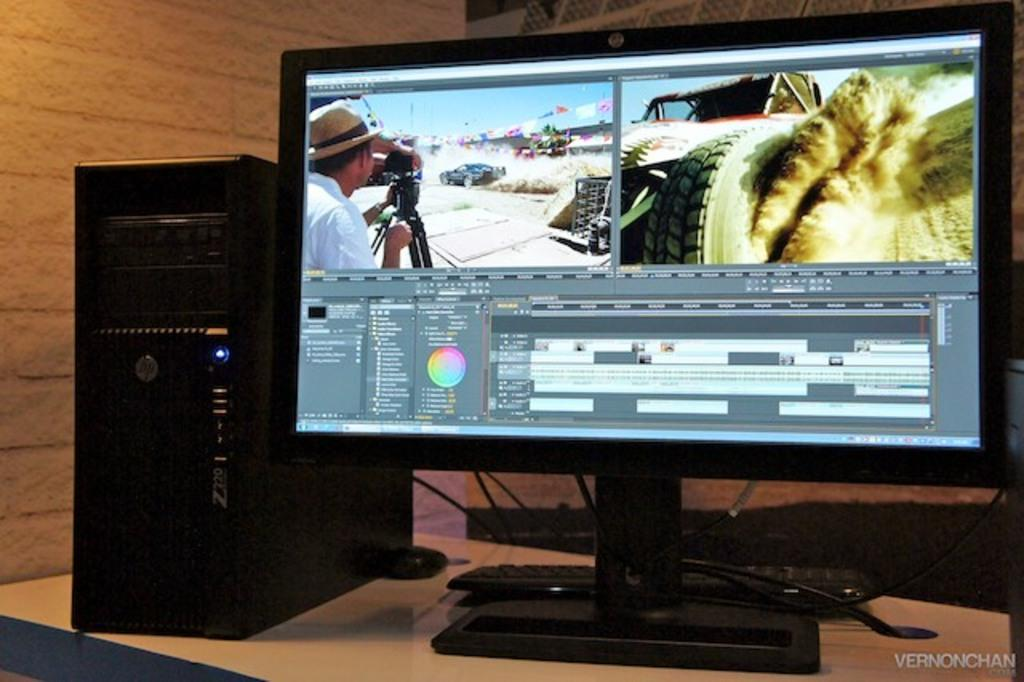Provide a one-sentence caption for the provided image. a computer that has the letters HP on it. 